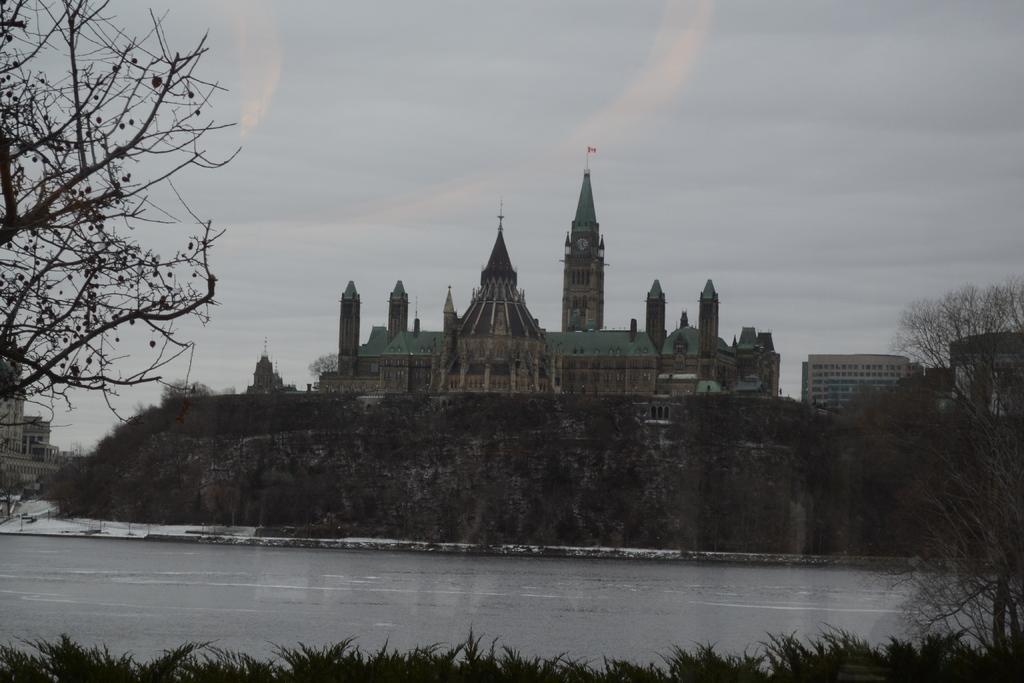Describe this image in one or two sentences. In this picture we can see water, few trees and buildings, in the background we can see clouds. 